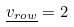Convert formula to latex. <formula><loc_0><loc_0><loc_500><loc_500>\underline { v _ { r o w } } = 2</formula> 